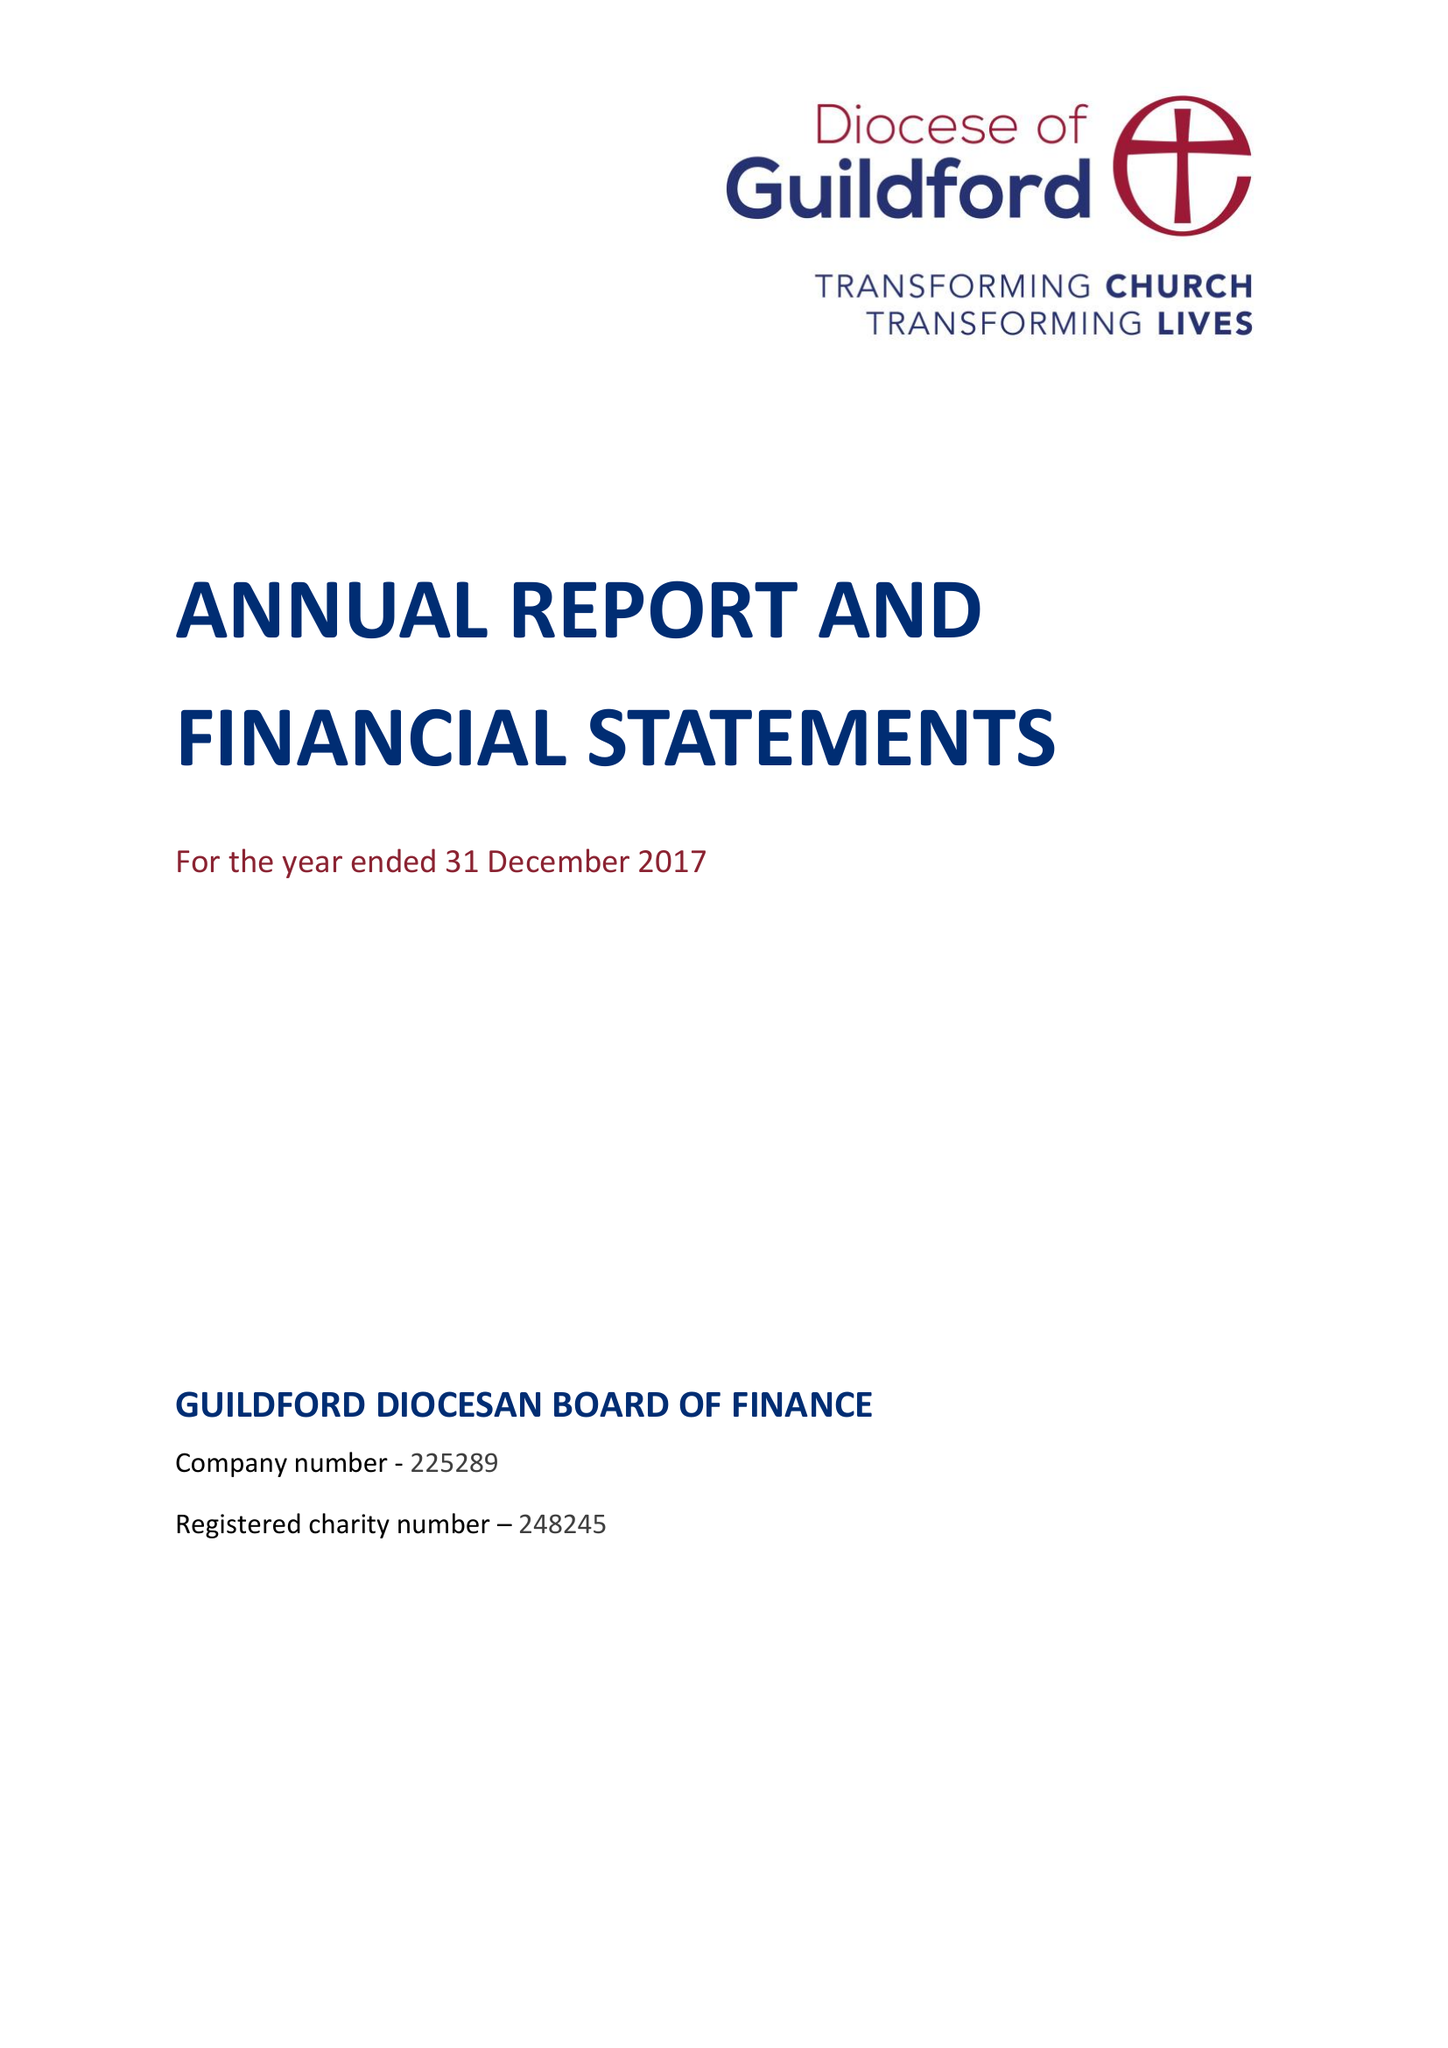What is the value for the address__postcode?
Answer the question using a single word or phrase. GU2 7YF 